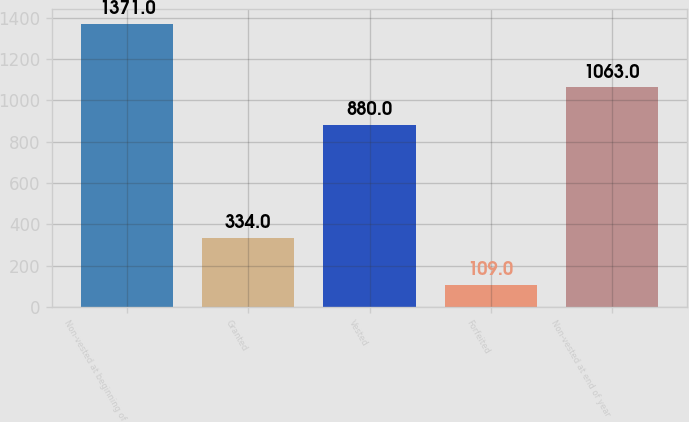<chart> <loc_0><loc_0><loc_500><loc_500><bar_chart><fcel>Non-vested at beginning of<fcel>Granted<fcel>Vested<fcel>Forfeited<fcel>Non-vested at end of year<nl><fcel>1371<fcel>334<fcel>880<fcel>109<fcel>1063<nl></chart> 